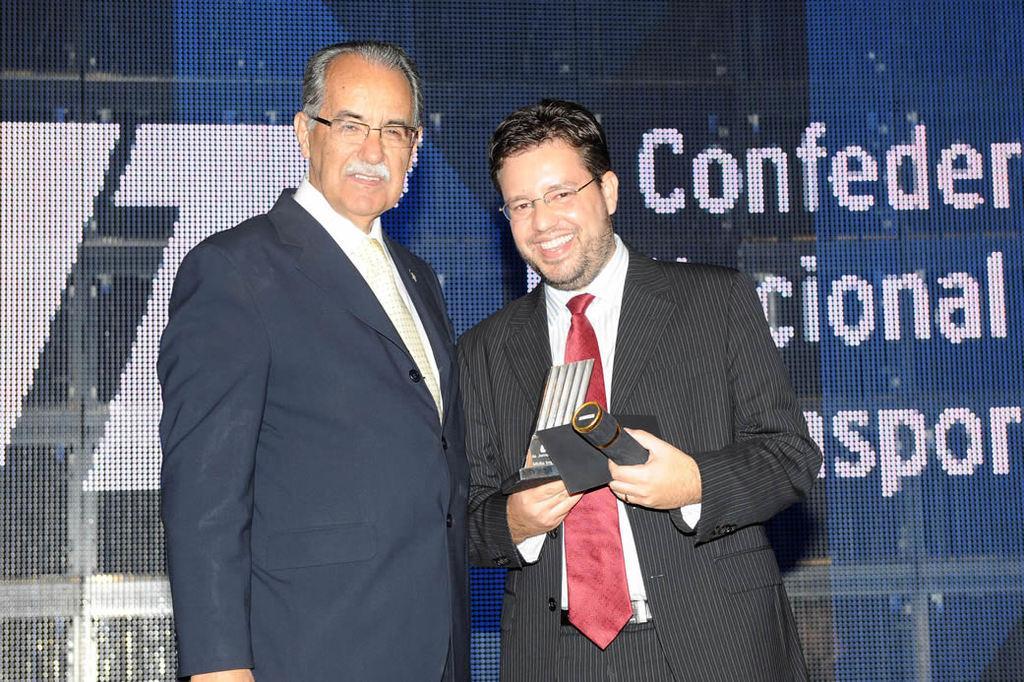Describe this image in one or two sentences. In this image I can see two persons standing, the person at right is wearing black blazer and white color shirt and holding the microphone and the background is in blue and black color and something is written on it. 